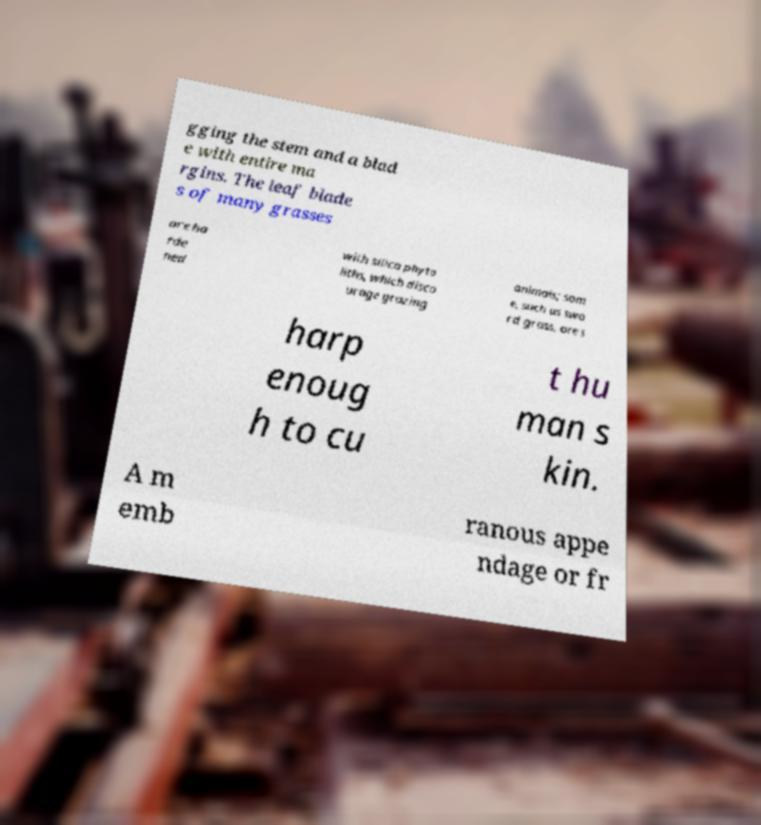There's text embedded in this image that I need extracted. Can you transcribe it verbatim? gging the stem and a blad e with entire ma rgins. The leaf blade s of many grasses are ha rde ned with silica phyto liths, which disco urage grazing animals; som e, such as swo rd grass, are s harp enoug h to cu t hu man s kin. A m emb ranous appe ndage or fr 